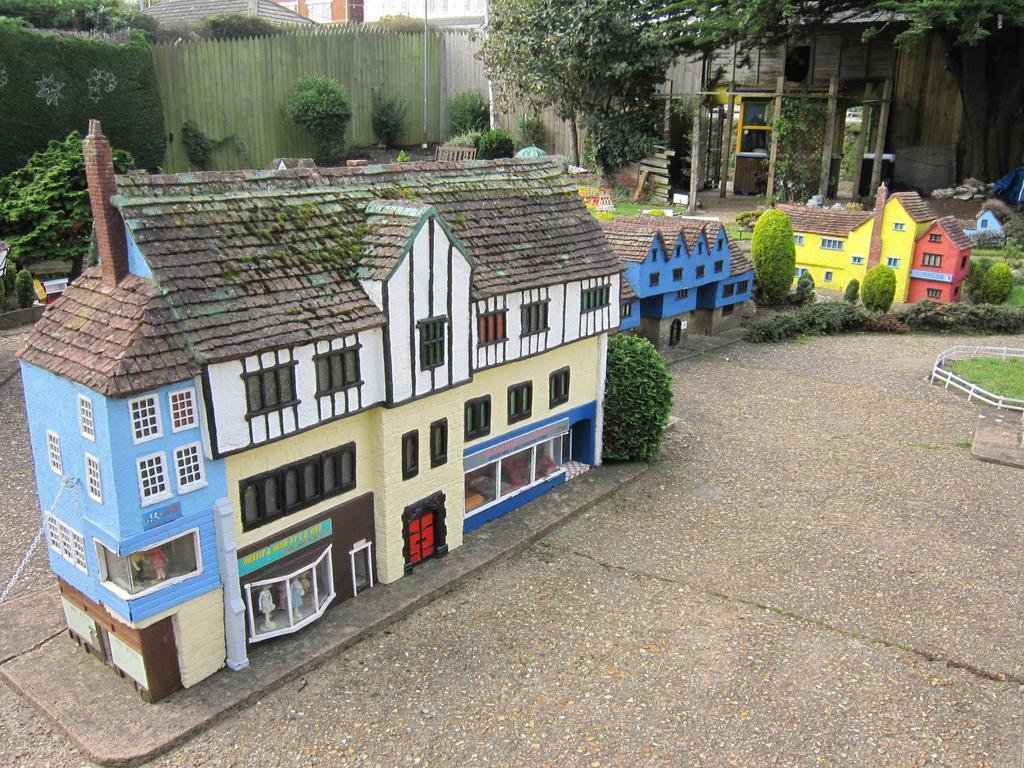How would you summarize this image in a sentence or two? In this picture, there are miniature arts of buildings. In between them, there are tiny plants. In the background, there are trees and plants. 